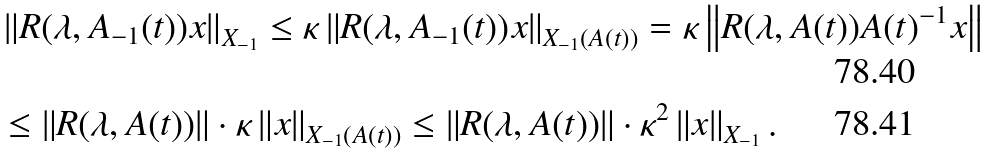<formula> <loc_0><loc_0><loc_500><loc_500>& \left \| R ( \lambda , A _ { - 1 } ( t ) ) x \right \| _ { X _ { - 1 } } \leq \kappa \left \| R ( \lambda , A _ { - 1 } ( t ) ) x \right \| _ { X _ { - 1 } ( A ( t ) ) } = \kappa \left \| R ( \lambda , A ( t ) ) A ( t ) ^ { - 1 } x \right \| \\ & \leq \left \| R ( \lambda , A ( t ) ) \right \| \cdot \kappa \left \| x \right \| _ { X _ { - 1 } ( A ( t ) ) } \leq \left \| R ( \lambda , A ( t ) ) \right \| \cdot \kappa ^ { 2 } \left \| x \right \| _ { X _ { - 1 } } .</formula> 